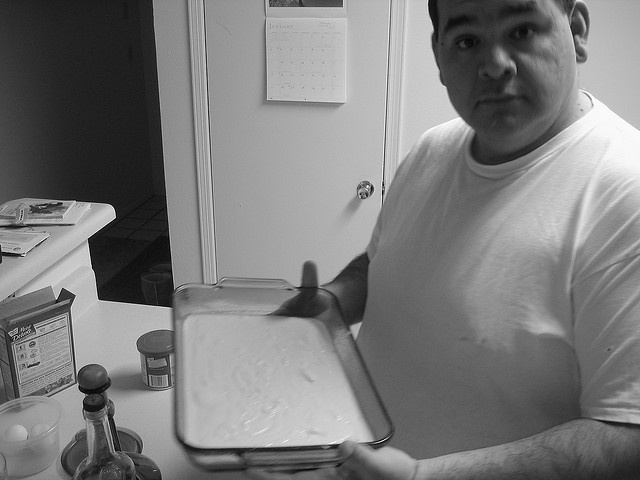Describe the objects in this image and their specific colors. I can see people in black, gray, darkgray, and gainsboro tones, cake in black, darkgray, lightgray, and gray tones, bowl in black, darkgray, gray, and lightgray tones, bottle in black, gray, and darkgray tones, and bottle in black, gray, and lightgray tones in this image. 